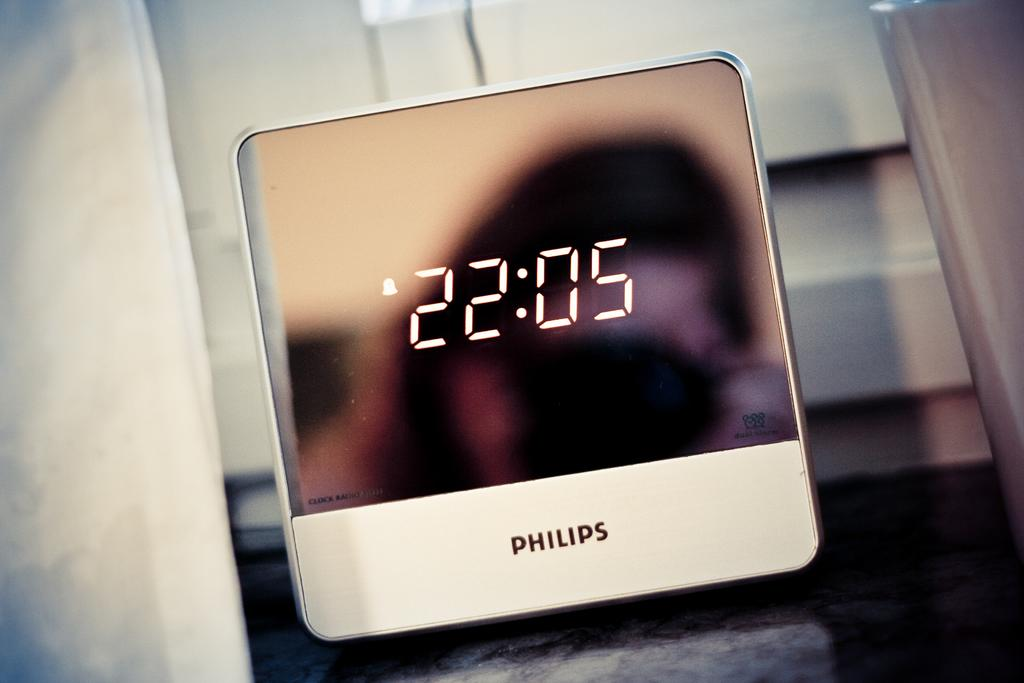<image>
Summarize the visual content of the image. A Philips clock displays the time of 22:05. 